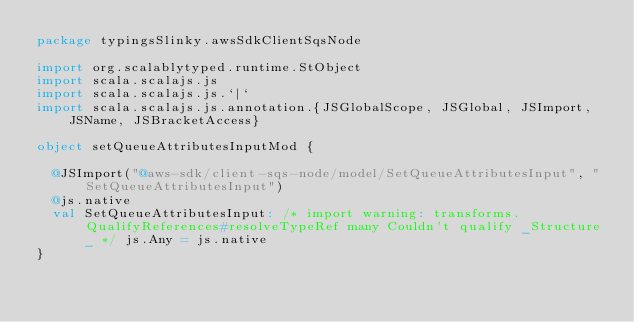Convert code to text. <code><loc_0><loc_0><loc_500><loc_500><_Scala_>package typingsSlinky.awsSdkClientSqsNode

import org.scalablytyped.runtime.StObject
import scala.scalajs.js
import scala.scalajs.js.`|`
import scala.scalajs.js.annotation.{JSGlobalScope, JSGlobal, JSImport, JSName, JSBracketAccess}

object setQueueAttributesInputMod {
  
  @JSImport("@aws-sdk/client-sqs-node/model/SetQueueAttributesInput", "SetQueueAttributesInput")
  @js.native
  val SetQueueAttributesInput: /* import warning: transforms.QualifyReferences#resolveTypeRef many Couldn't qualify _Structure_ */ js.Any = js.native
}
</code> 